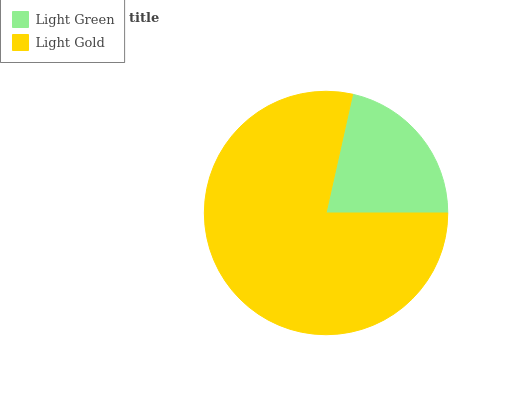Is Light Green the minimum?
Answer yes or no. Yes. Is Light Gold the maximum?
Answer yes or no. Yes. Is Light Gold the minimum?
Answer yes or no. No. Is Light Gold greater than Light Green?
Answer yes or no. Yes. Is Light Green less than Light Gold?
Answer yes or no. Yes. Is Light Green greater than Light Gold?
Answer yes or no. No. Is Light Gold less than Light Green?
Answer yes or no. No. Is Light Gold the high median?
Answer yes or no. Yes. Is Light Green the low median?
Answer yes or no. Yes. Is Light Green the high median?
Answer yes or no. No. Is Light Gold the low median?
Answer yes or no. No. 